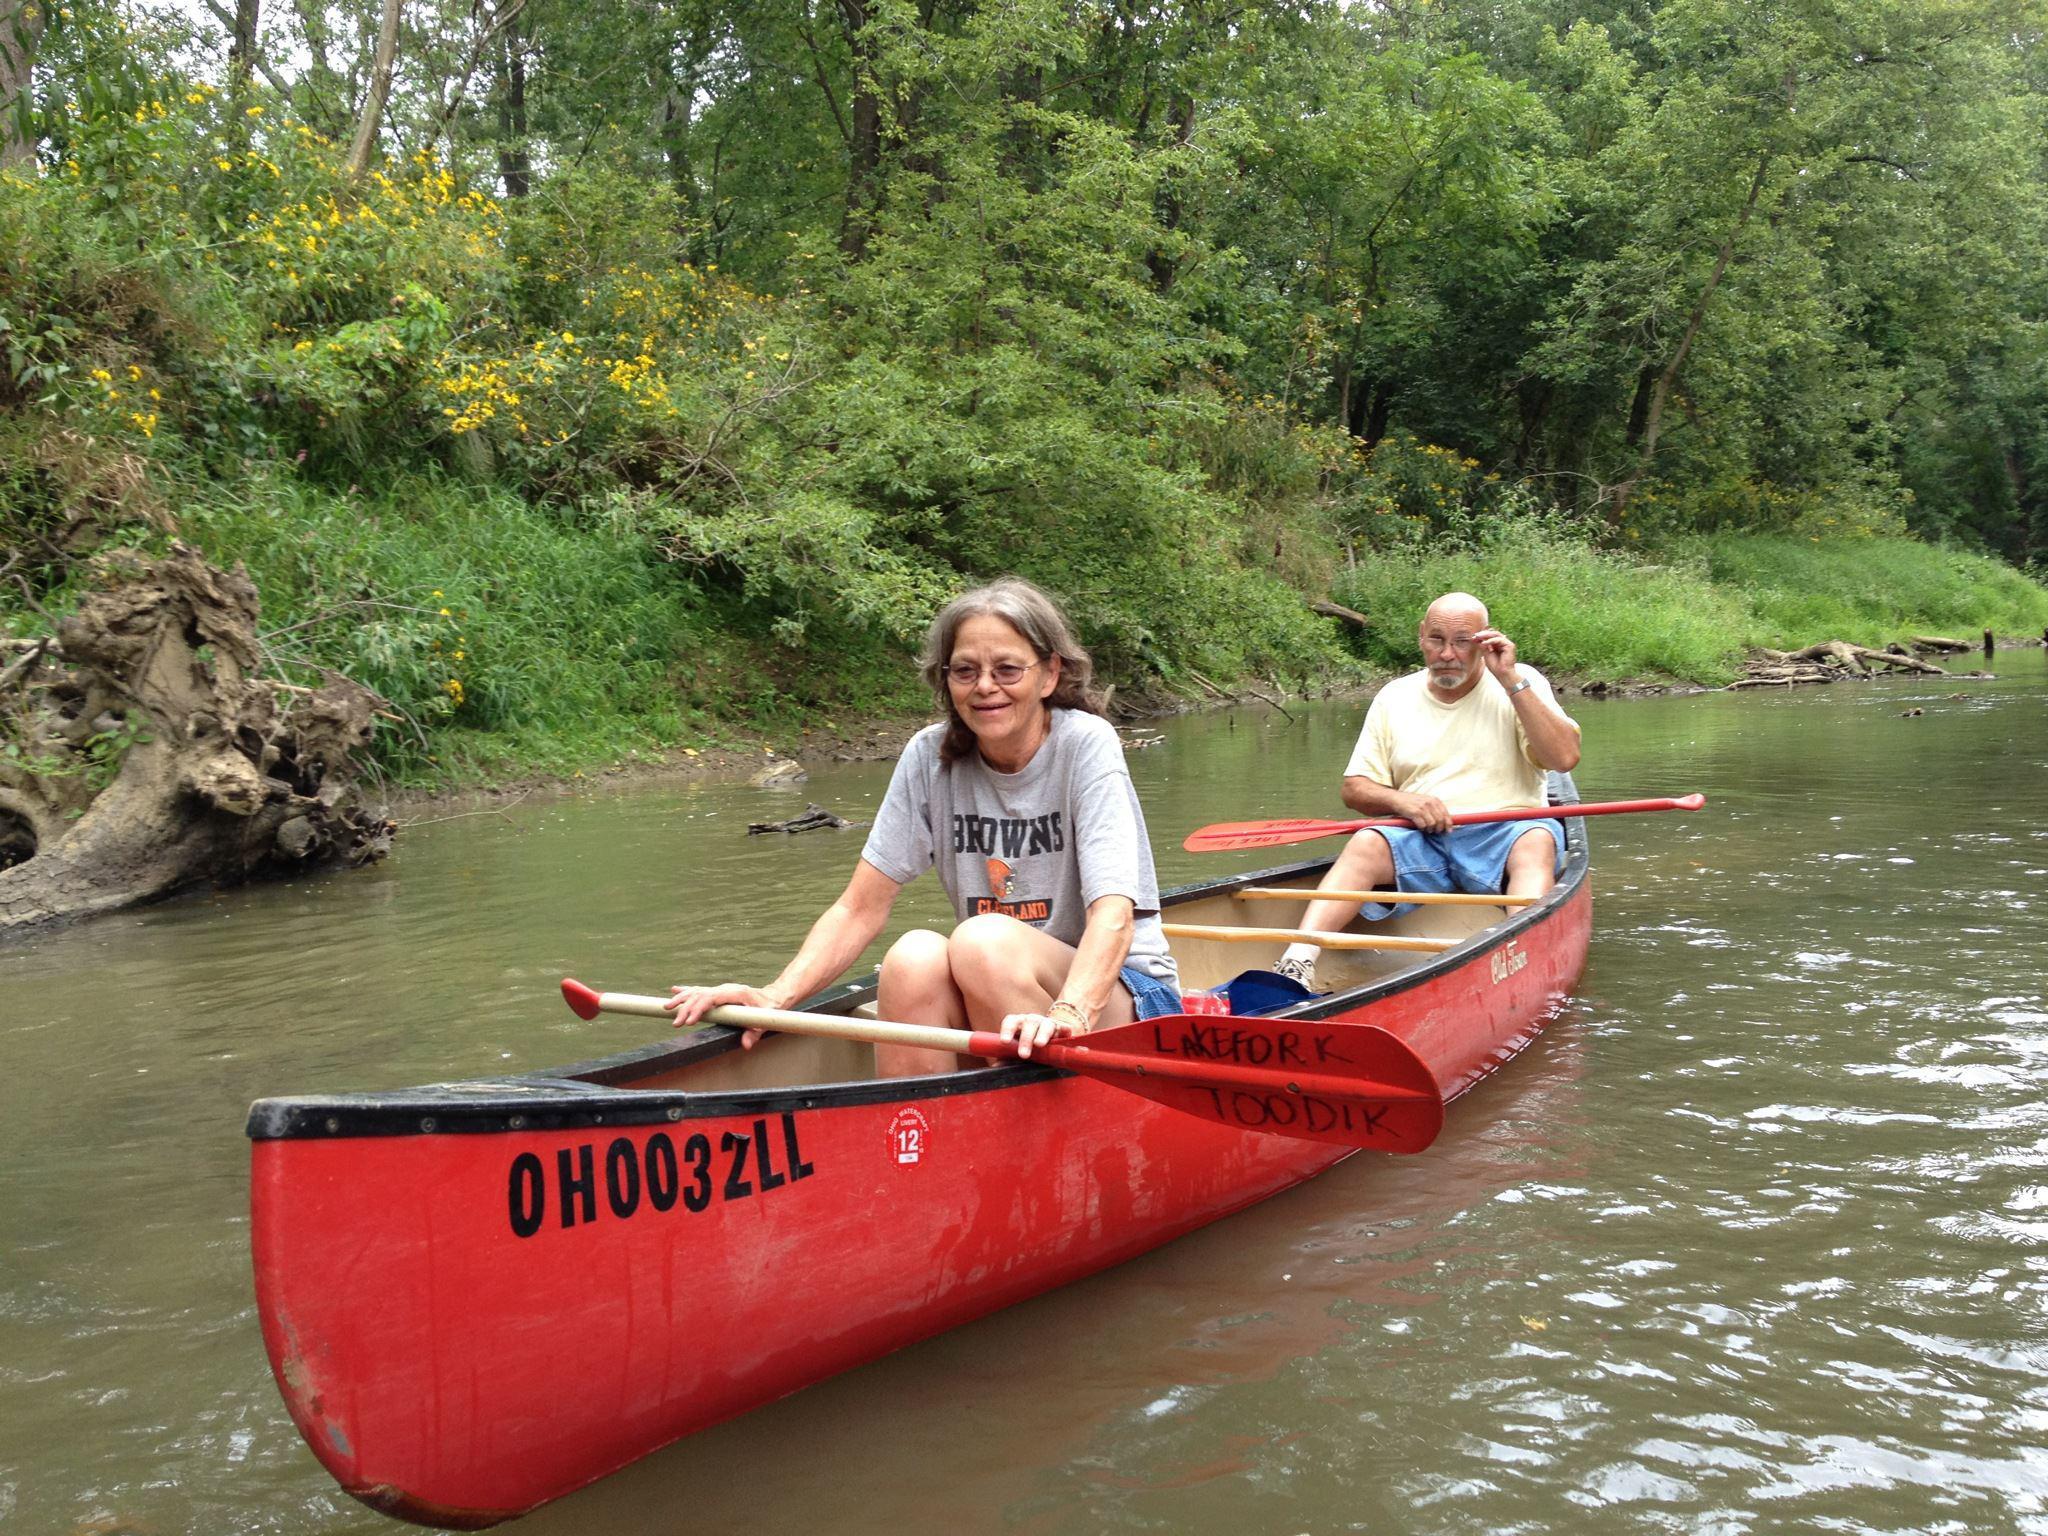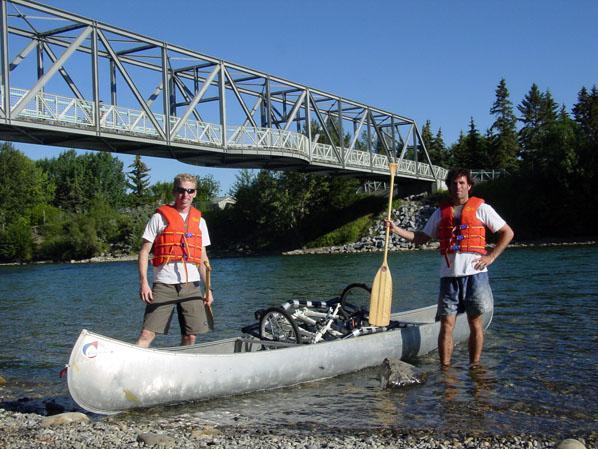The first image is the image on the left, the second image is the image on the right. Evaluate the accuracy of this statement regarding the images: "The left and right image contains the same number of boats.". Is it true? Answer yes or no. Yes. The first image is the image on the left, the second image is the image on the right. For the images displayed, is the sentence "The left image features one light brown canoe with a white circle on its front, heading rightward with at least six people sitting in it." factually correct? Answer yes or no. No. 